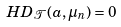Convert formula to latex. <formula><loc_0><loc_0><loc_500><loc_500>H D _ { \mathcal { T } } ( a , \mu _ { n } ) = 0</formula> 